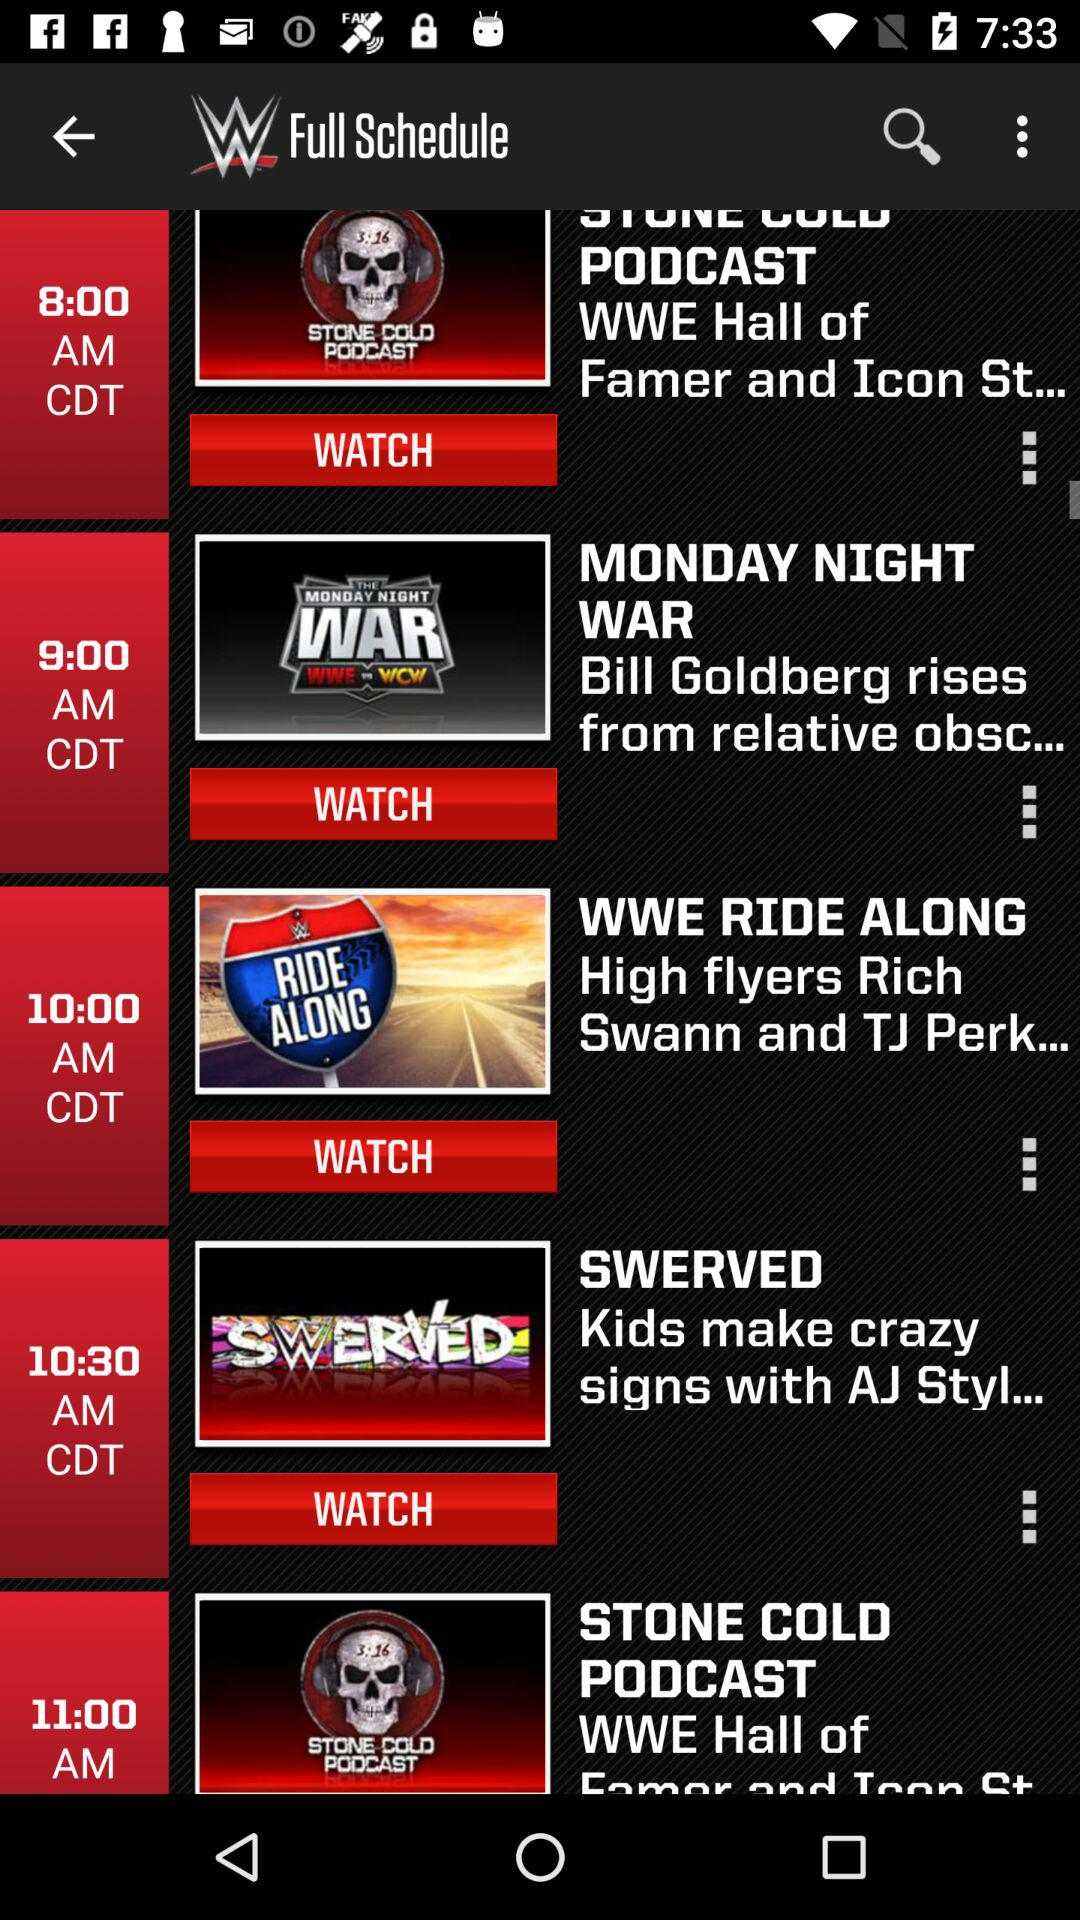What is the time of "SWERVED"? The time is 10:30 AM. 